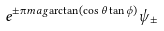<formula> <loc_0><loc_0><loc_500><loc_500>e ^ { \pm \i m a g \arctan ( \cos \theta \tan \phi ) } \psi _ { \pm }</formula> 